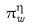Convert formula to latex. <formula><loc_0><loc_0><loc_500><loc_500>\pi _ { w } ^ { \eta }</formula> 